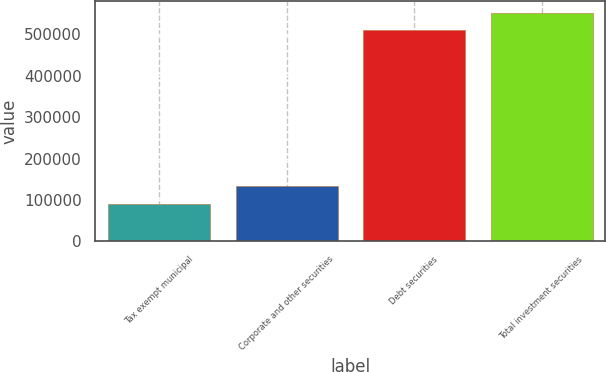Convert chart. <chart><loc_0><loc_0><loc_500><loc_500><bar_chart><fcel>Tax exempt municipal<fcel>Corporate and other securities<fcel>Debt securities<fcel>Total investment securities<nl><fcel>90705<fcel>132651<fcel>510167<fcel>552113<nl></chart> 